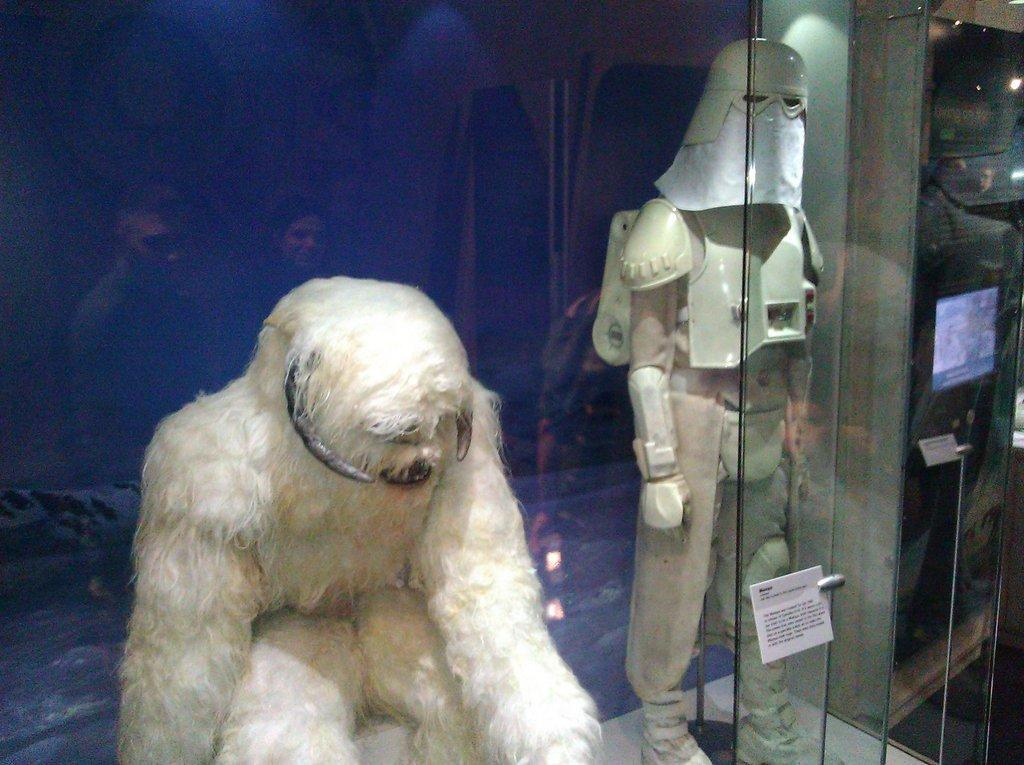What is located behind the glass wall in the image? Unfortunately, the specific object or scene behind the glass wall cannot be determined from the provided facts. What is present on the glass wall in the image? The facts do not specify what is on the glass wall, so we cannot provide a definitive answer. Is the glass wall being used to make jam in the image? There is no mention of jam or any food-related activity in the image, so we cannot answer this question definitively. 